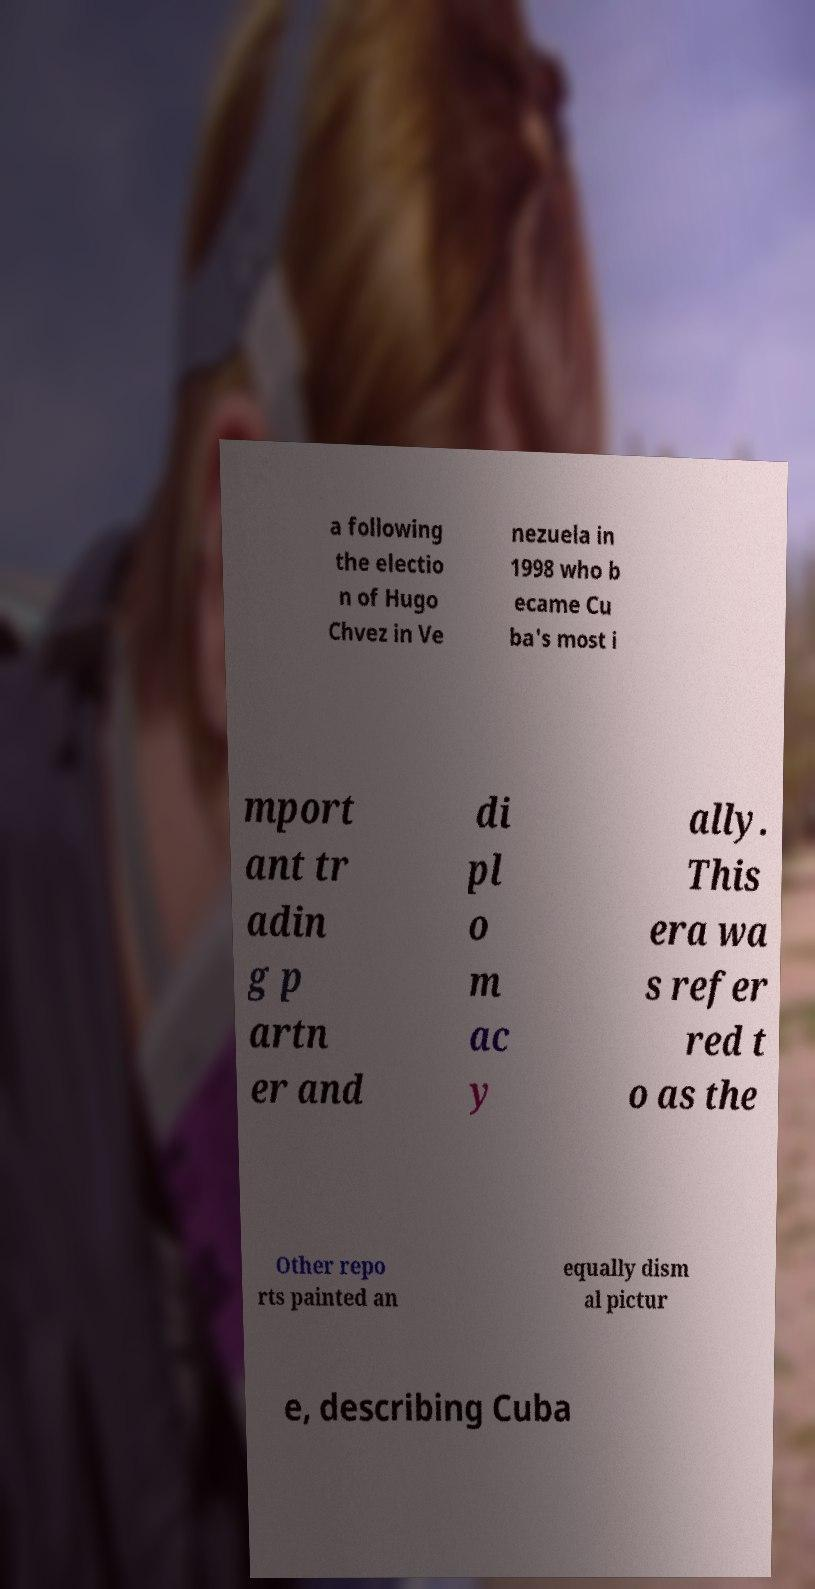What messages or text are displayed in this image? I need them in a readable, typed format. a following the electio n of Hugo Chvez in Ve nezuela in 1998 who b ecame Cu ba's most i mport ant tr adin g p artn er and di pl o m ac y ally. This era wa s refer red t o as the Other repo rts painted an equally dism al pictur e, describing Cuba 